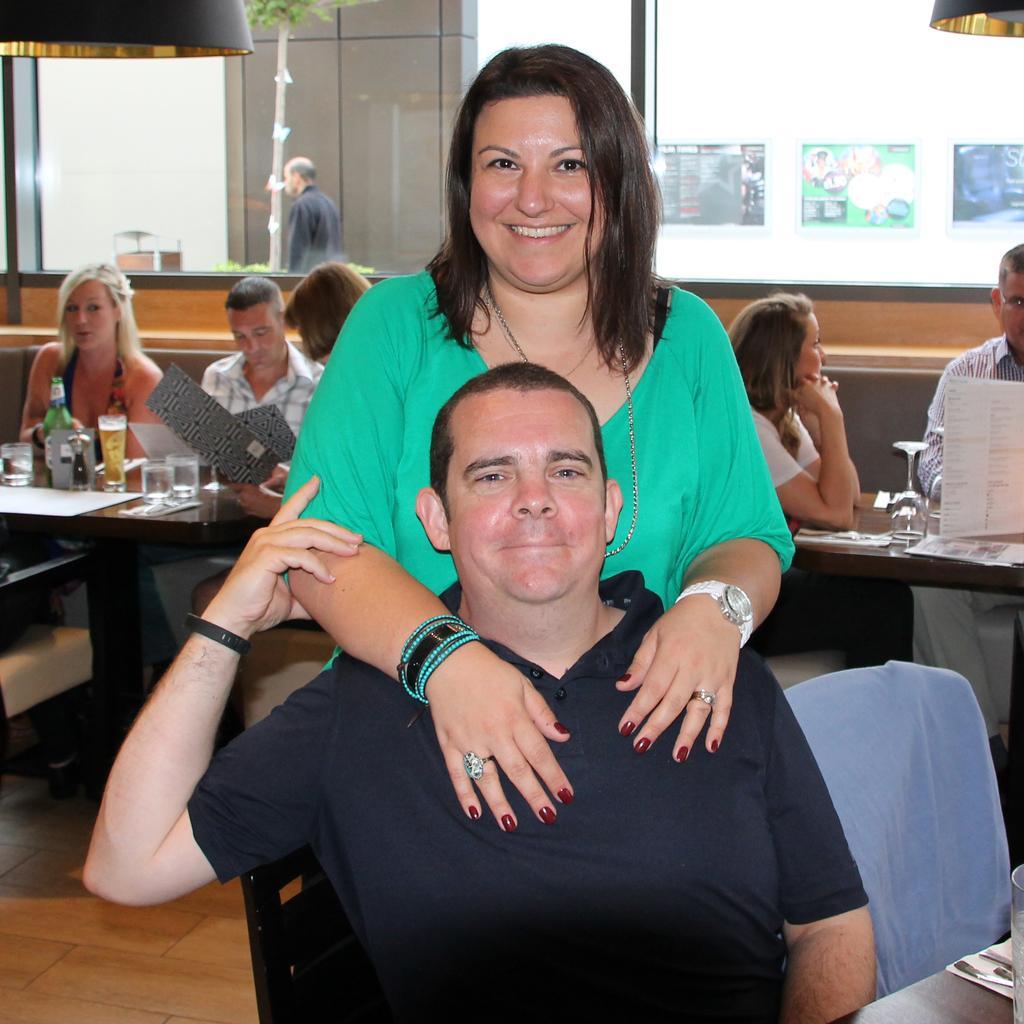Describe this image in one or two sentences. This picture describes about group of people few are seated on the chair and few are standing, in the middle of the given image a woman is standing behind to the man and she is smiling, in the background we can find couple of buildings and a plant. 